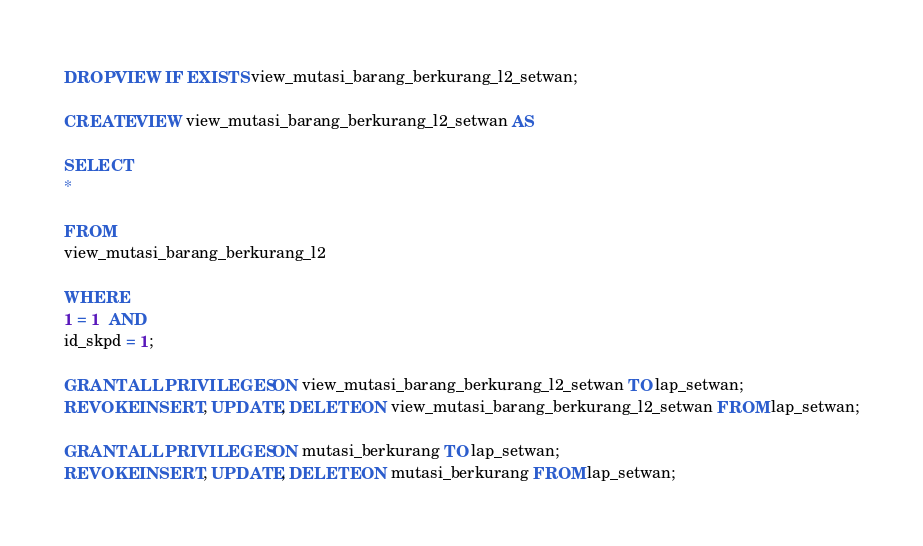<code> <loc_0><loc_0><loc_500><loc_500><_SQL_>DROP VIEW IF EXISTS view_mutasi_barang_berkurang_l2_setwan;

CREATE VIEW view_mutasi_barang_berkurang_l2_setwan AS

SELECT
*

FROM
view_mutasi_barang_berkurang_l2

WHERE
1 = 1  AND
id_skpd = 1;

GRANT ALL PRIVILEGES ON view_mutasi_barang_berkurang_l2_setwan TO lap_setwan;
REVOKE INSERT, UPDATE, DELETE ON view_mutasi_barang_berkurang_l2_setwan FROM lap_setwan;

GRANT ALL PRIVILEGES ON mutasi_berkurang TO lap_setwan;
REVOKE INSERT, UPDATE, DELETE ON mutasi_berkurang FROM lap_setwan;
</code> 